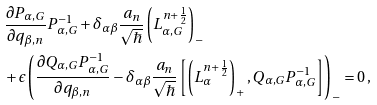<formula> <loc_0><loc_0><loc_500><loc_500>& \frac { \partial P _ { \alpha , G } } { \partial q _ { \beta , n } } P _ { \alpha , G } ^ { - 1 } + \delta _ { \alpha \beta } \frac { a _ { n } } { \sqrt { \hbar } } \left ( L _ { \alpha , G } ^ { n + \frac { 1 } { 2 } } \right ) _ { - } \\ & + \epsilon \left ( \frac { \partial Q _ { \alpha , G } P _ { \alpha , G } ^ { - 1 } } { \partial q _ { \beta , n } } - \delta _ { \alpha \beta } \frac { a _ { n } } { \sqrt { \hbar } } \left [ \left ( L _ { \alpha } ^ { n + \frac { 1 } { 2 } } \right ) _ { + } , Q _ { \alpha , G } P _ { \alpha , G } ^ { - 1 } \right ] \right ) _ { - } = 0 \, ,</formula> 